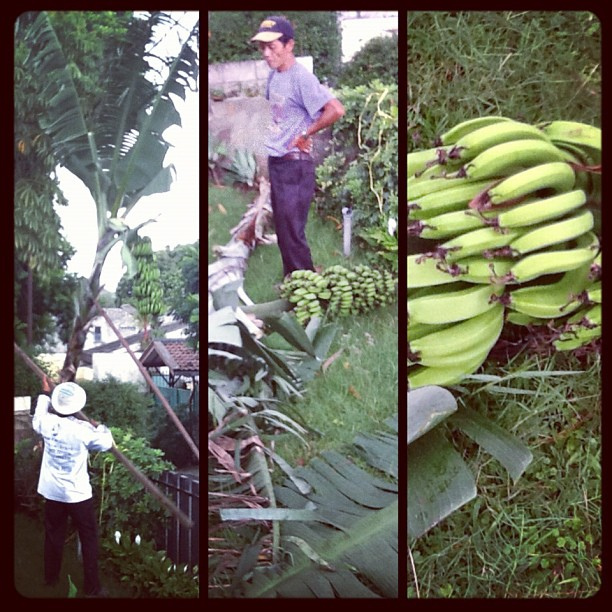<image>What kind of vegetable is growing? I don't know. It can be seen as banana but banana isn't a vegetable. What kind of vegetable is growing? I don't know what kind of vegetable is growing. It can be bananas. 